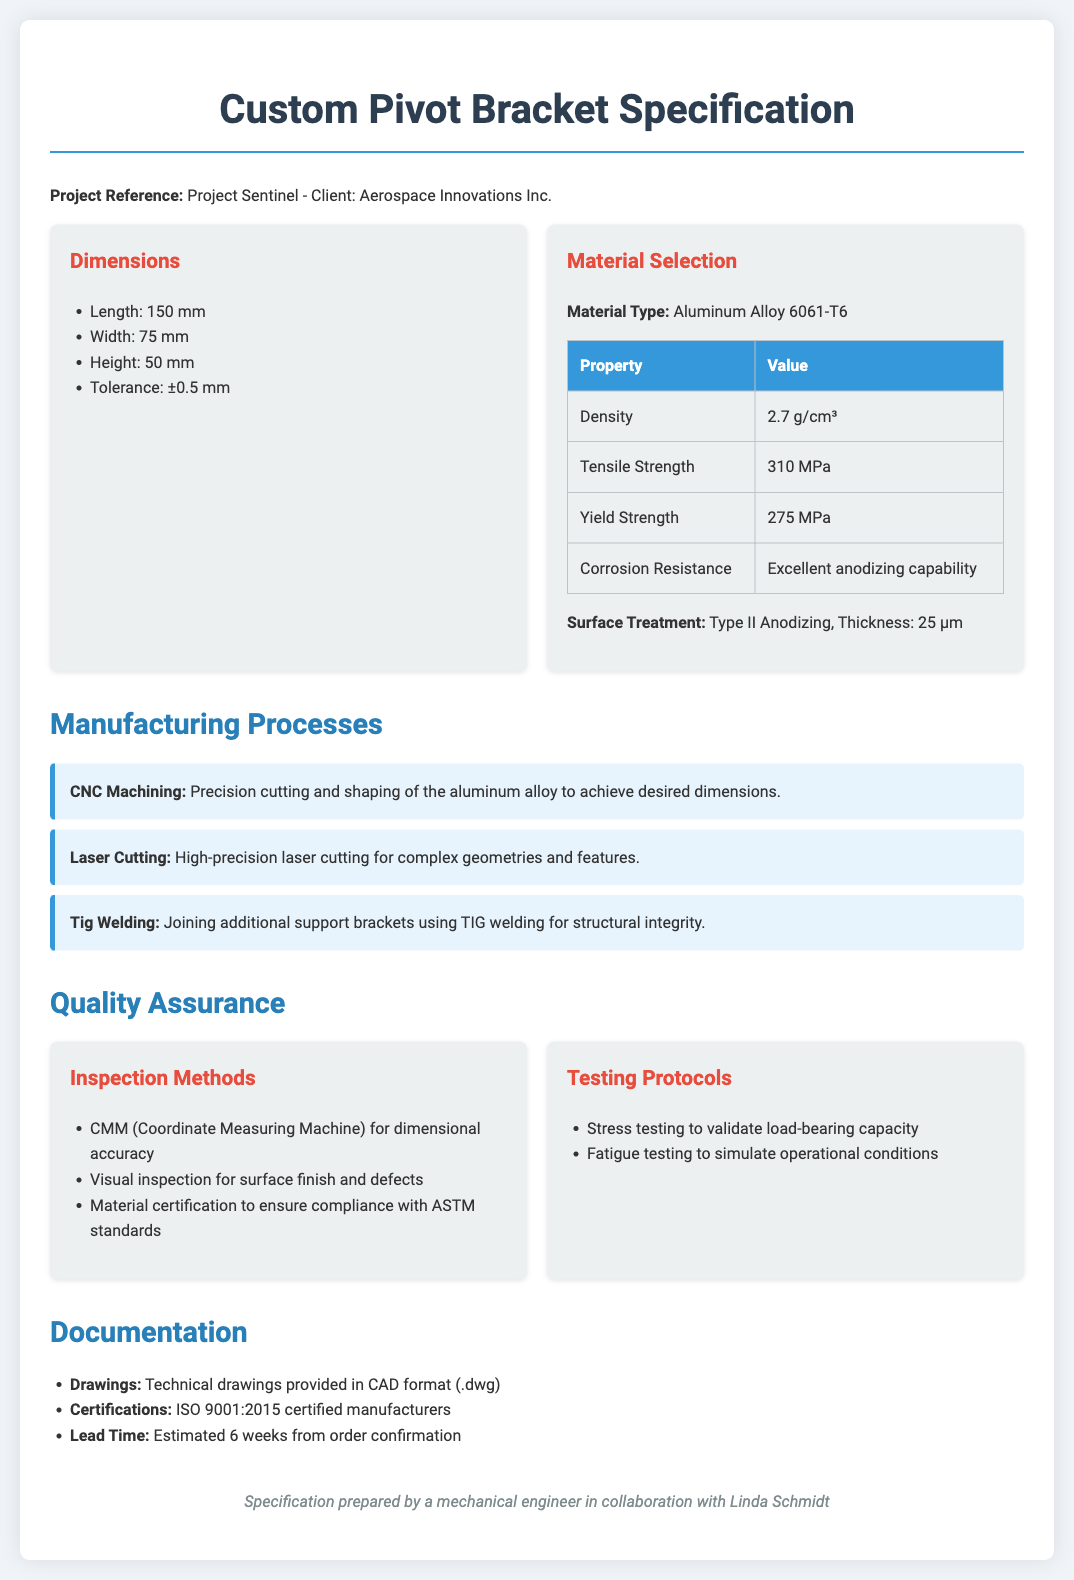What is the project reference? The project reference is provided in the document header, specifying the project name and client.
Answer: Project Sentinel - Client: Aerospace Innovations Inc What are the dimensions of the component? The dimensions include length, width, height, and tolerance, which are listed under the dimensions section.
Answer: Length: 150 mm, Width: 75 mm, Height: 50 mm, Tolerance: ±0.5 mm What material is selected for the component? The material selection section specifies the type of material chosen for the component.
Answer: Aluminum Alloy 6061-T6 What is the tensile strength of the material? The tensile strength is provided in the material properties table.
Answer: 310 MPa How many manufacturing processes are listed? The document outlines several manufacturing processes under the respective section, which can be counted.
Answer: 3 What surface treatment is specified? The surface treatment details are outlined in the material selection section of the document.
Answer: Type II Anodizing, Thickness: 25 µm What is the estimated lead time for delivery? The lead time is mentioned in the documentation section of the specification.
Answer: Estimated 6 weeks from order confirmation Which inspection method is used for dimensional accuracy? The inspection methods section lists various techniques used during quality assurance.
Answer: CMM (Coordinate Measuring Machine) What is the certification status of the manufacturers? The certifications mentioned in the documentation section provide information on the manufacturers' quality standard.
Answer: ISO 9001:2015 certified manufacturers 